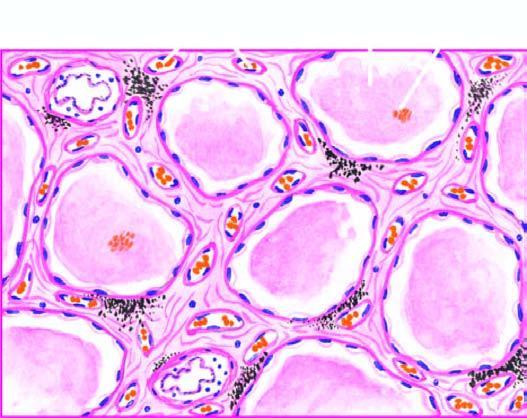re the dead cell seen in singles congested?
Answer the question using a single word or phrase. No 